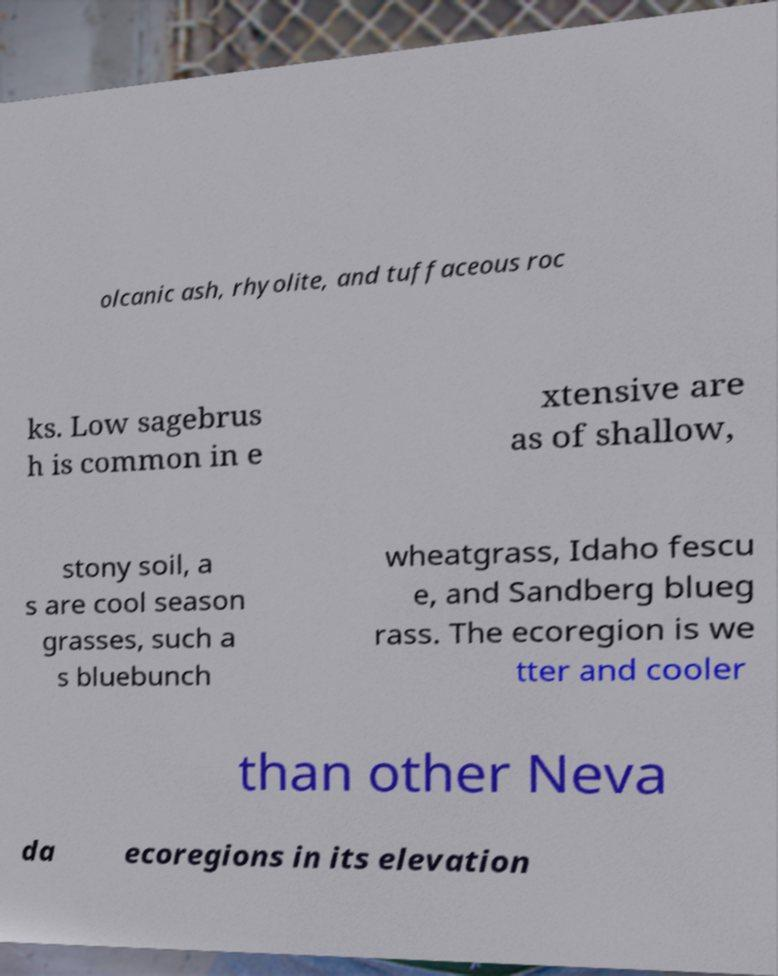I need the written content from this picture converted into text. Can you do that? olcanic ash, rhyolite, and tuffaceous roc ks. Low sagebrus h is common in e xtensive are as of shallow, stony soil, a s are cool season grasses, such a s bluebunch wheatgrass, Idaho fescu e, and Sandberg blueg rass. The ecoregion is we tter and cooler than other Neva da ecoregions in its elevation 